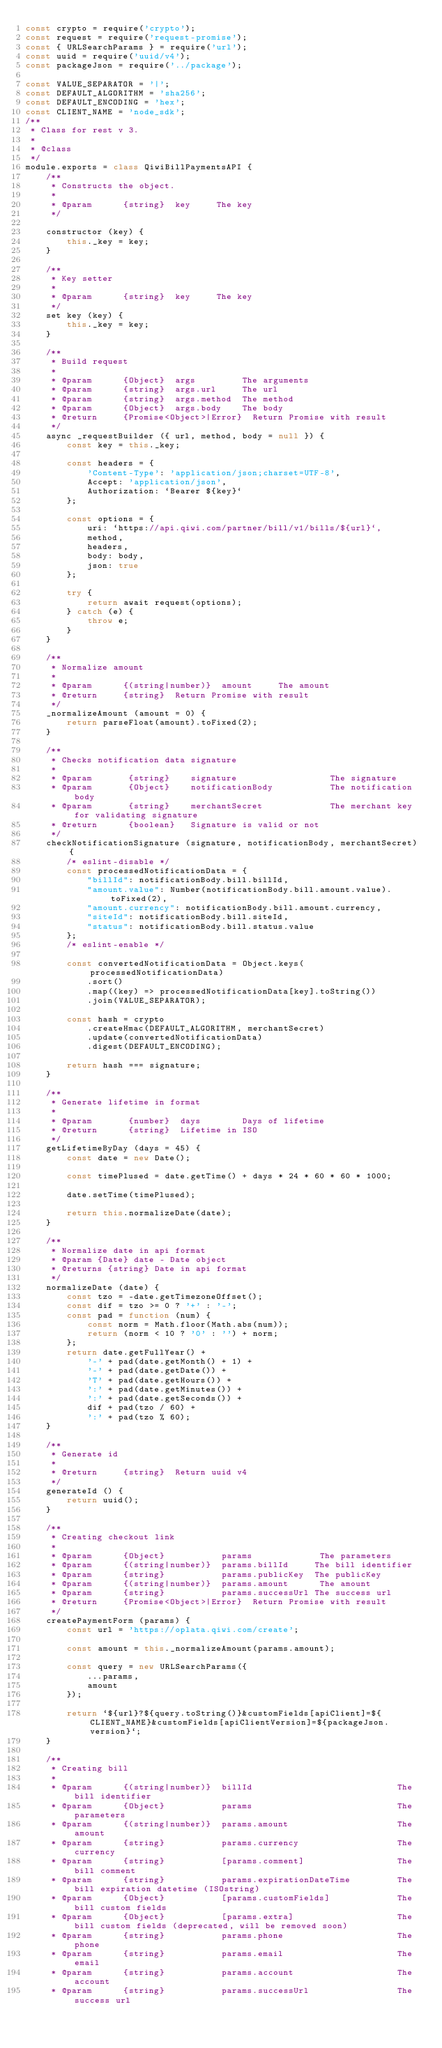Convert code to text. <code><loc_0><loc_0><loc_500><loc_500><_JavaScript_>const crypto = require('crypto');
const request = require('request-promise');
const { URLSearchParams } = require('url');
const uuid = require('uuid/v4');
const packageJson = require('../package');

const VALUE_SEPARATOR = '|';
const DEFAULT_ALGORITHM = 'sha256';
const DEFAULT_ENCODING = 'hex';
const CLIENT_NAME = 'node_sdk';
/**
 * Class for rest v 3.
 *
 * @class
 */
module.exports = class QiwiBillPaymentsAPI {
    /**
     * Constructs the object.
     *
     * @param      {string}  key     The key
     */

    constructor (key) {
        this._key = key;
    }

    /**
     * Key setter
     *
     * @param      {string}  key     The key
     */
    set key (key) {
        this._key = key;
    }

    /**
     * Build request
     *
     * @param      {Object}  args         The arguments
     * @param      {string}  args.url     The url
     * @param      {string}  args.method  The method
     * @param      {Object}  args.body    The body
     * @return     {Promise<Object>|Error}  Return Promise with result
     */
    async _requestBuilder ({ url, method, body = null }) {
        const key = this._key;

        const headers = {
            'Content-Type': 'application/json;charset=UTF-8',
            Accept: 'application/json',
            Authorization: `Bearer ${key}`
        };

        const options = {
            uri: `https://api.qiwi.com/partner/bill/v1/bills/${url}`,
            method,
            headers,
            body: body,
            json: true
        };

        try {
            return await request(options);
        } catch (e) {
            throw e;
        }
    }

    /**
     * Normalize amount
     *
     * @param      {(string|number)}  amount     The amount
     * @return     {string}  Return Promise with result
     */
    _normalizeAmount (amount = 0) {
        return parseFloat(amount).toFixed(2);
    }

    /**
     * Checks notification data signature
     *
     * @param       {string}    signature                  The signature
     * @param       {Object}    notificationBody           The notification body
     * @param       {string}    merchantSecret             The merchant key for validating signature
     * @return      {boolean}   Signature is valid or not
     */
    checkNotificationSignature (signature, notificationBody, merchantSecret) {
        /* eslint-disable */
        const processedNotificationData = {
            "billId": notificationBody.bill.billId,
            "amount.value": Number(notificationBody.bill.amount.value).toFixed(2),
            "amount.currency": notificationBody.bill.amount.currency,
            "siteId": notificationBody.bill.siteId,
            "status": notificationBody.bill.status.value
        };
        /* eslint-enable */

        const convertedNotificationData = Object.keys(processedNotificationData)
            .sort()
            .map((key) => processedNotificationData[key].toString())
            .join(VALUE_SEPARATOR);

        const hash = crypto
            .createHmac(DEFAULT_ALGORITHM, merchantSecret)
            .update(convertedNotificationData)
            .digest(DEFAULT_ENCODING);

        return hash === signature;
    }

    /**
     * Generate lifetime in format
     *
     * @param       {number}  days        Days of lifetime
     * @return      {string}  Lifetime in ISO
     */
    getLifetimeByDay (days = 45) {
        const date = new Date();

        const timePlused = date.getTime() + days * 24 * 60 * 60 * 1000;

        date.setTime(timePlused);

        return this.normalizeDate(date);
    }

    /**
     * Normalize date in api format
     * @param {Date} date - Date object
     * @returns {string} Date in api format
     */
    normalizeDate (date) {
        const tzo = -date.getTimezoneOffset();
        const dif = tzo >= 0 ? '+' : '-';
        const pad = function (num) {
            const norm = Math.floor(Math.abs(num));
            return (norm < 10 ? '0' : '') + norm;
        };
        return date.getFullYear() +
            '-' + pad(date.getMonth() + 1) +
            '-' + pad(date.getDate()) +
            'T' + pad(date.getHours()) +
            ':' + pad(date.getMinutes()) +
            ':' + pad(date.getSeconds()) +
            dif + pad(tzo / 60) +
            ':' + pad(tzo % 60);
    }

    /**
     * Generate id
     *
     * @return     {string}  Return uuid v4
     */
    generateId () {
        return uuid();
    }

    /**
     * Creating checkout link
     *
     * @param      {Object}           params             The parameters
     * @param      {(string|number)}  params.billId     The bill identifier
     * @param      {string}           params.publicKey  The publicKey
     * @param      {(string|number)}  params.amount      The amount
     * @param      {string}           params.successUrl The success url
     * @return     {Promise<Object>|Error}  Return Promise with result
     */
    createPaymentForm (params) {
        const url = 'https://oplata.qiwi.com/create';

        const amount = this._normalizeAmount(params.amount);

        const query = new URLSearchParams({
            ...params,
            amount
        });

        return `${url}?${query.toString()}&customFields[apiClient]=${CLIENT_NAME}&customFields[apiClientVersion]=${packageJson.version}`;
    }

    /**
     * Creating bill
     *
     * @param      {(string|number)}  billId                            The bill identifier
     * @param      {Object}           params                            The parameters
     * @param      {(string|number)}  params.amount                     The amount
     * @param      {string}           params.currency                   The currency
     * @param      {string}           [params.comment]                  The bill comment
     * @param      {string}           params.expirationDateTime         The bill expiration datetime (ISOstring)
     * @param      {Object}           [params.customFields]             The bill custom fields
     * @param      {Object}           [params.extra]                    The bill custom fields (deprecated, will be removed soon)
     * @param      {string}           params.phone                      The phone
     * @param      {string}           params.email                      The email
     * @param      {string}           params.account                    The account
     * @param      {string}           params.successUrl                 The success url</code> 